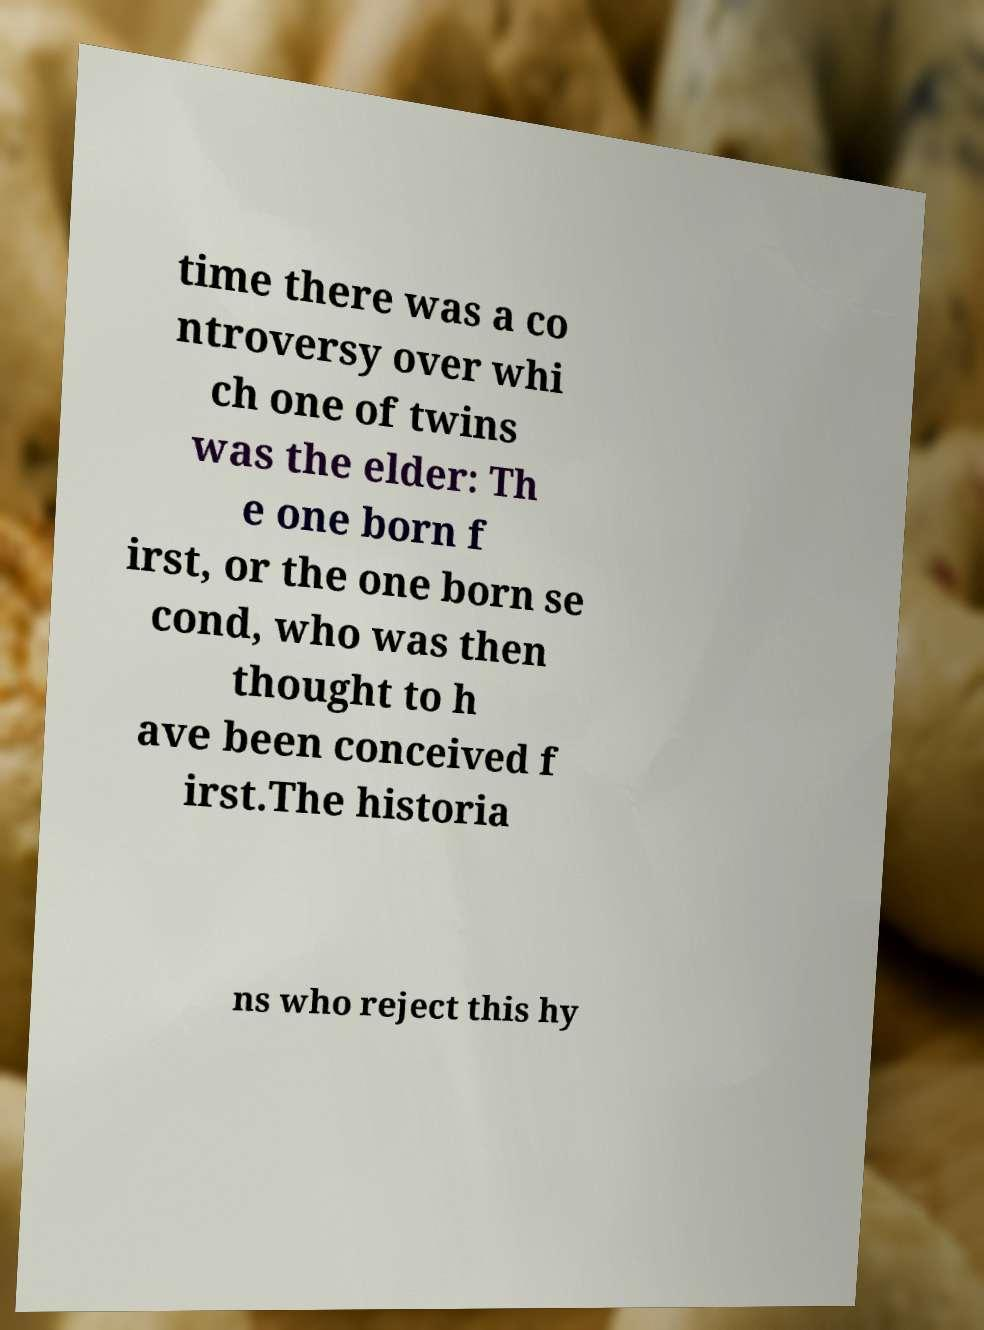What messages or text are displayed in this image? I need them in a readable, typed format. time there was a co ntroversy over whi ch one of twins was the elder: Th e one born f irst, or the one born se cond, who was then thought to h ave been conceived f irst.The historia ns who reject this hy 